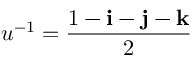Convert formula to latex. <formula><loc_0><loc_0><loc_500><loc_500>u ^ { - 1 } = { \frac { 1 - i - j - k } { 2 } }</formula> 